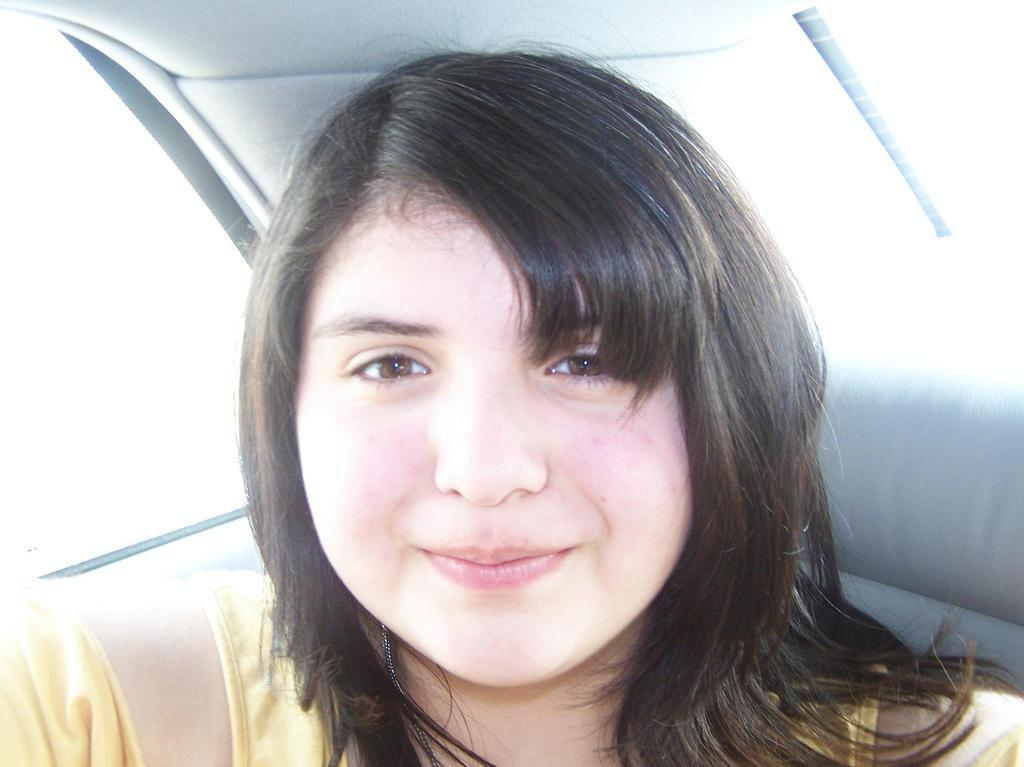Who is present in the image? There is a lady in the image. What is the lady doing in the image? The lady is sitting in a car. What type of pies can be seen on the train in the image? There is no train or pies present in the image; it features a lady sitting in a car. How many beads are visible on the lady's necklace in the image? There is no necklace or beads visible in the image; the lady is simply sitting in a car. 